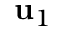<formula> <loc_0><loc_0><loc_500><loc_500>u _ { 1 }</formula> 